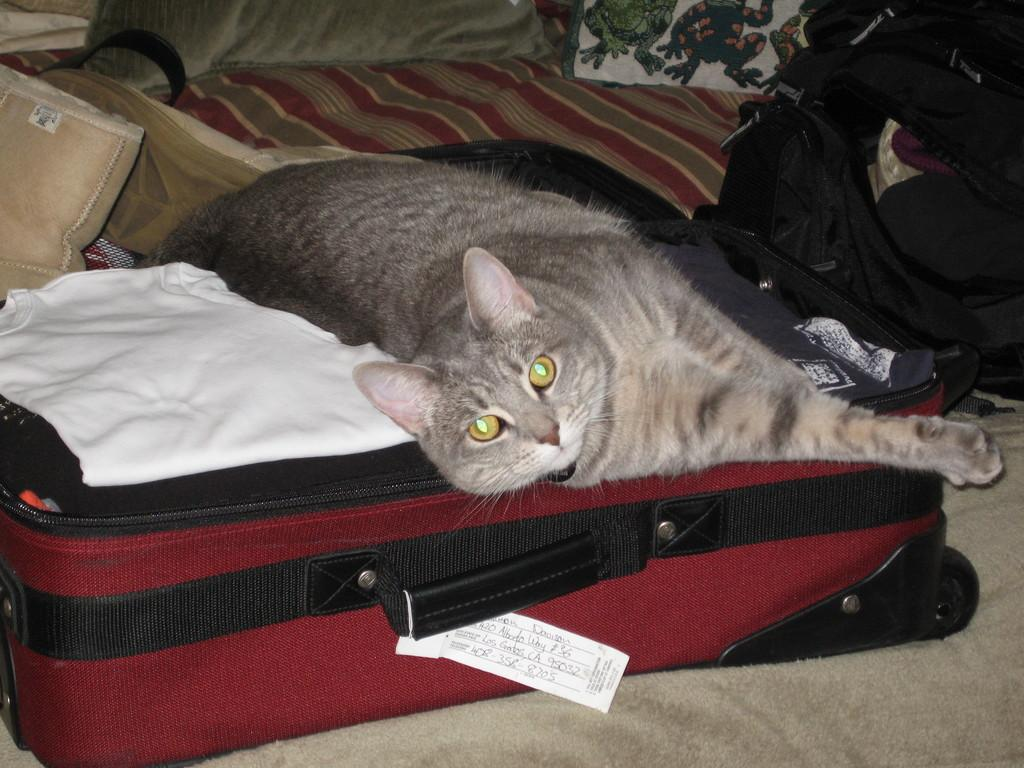What animal can be seen in the image? There is a cat in the image. What is the cat doing in the image? The cat is sleeping on a suitcase. Where is the suitcase located in the image? The suitcase is on a bed. What type of spoon is being used by the company in the image? There is no spoon or company present in the image; it features a cat sleeping on a suitcase on a bed. 